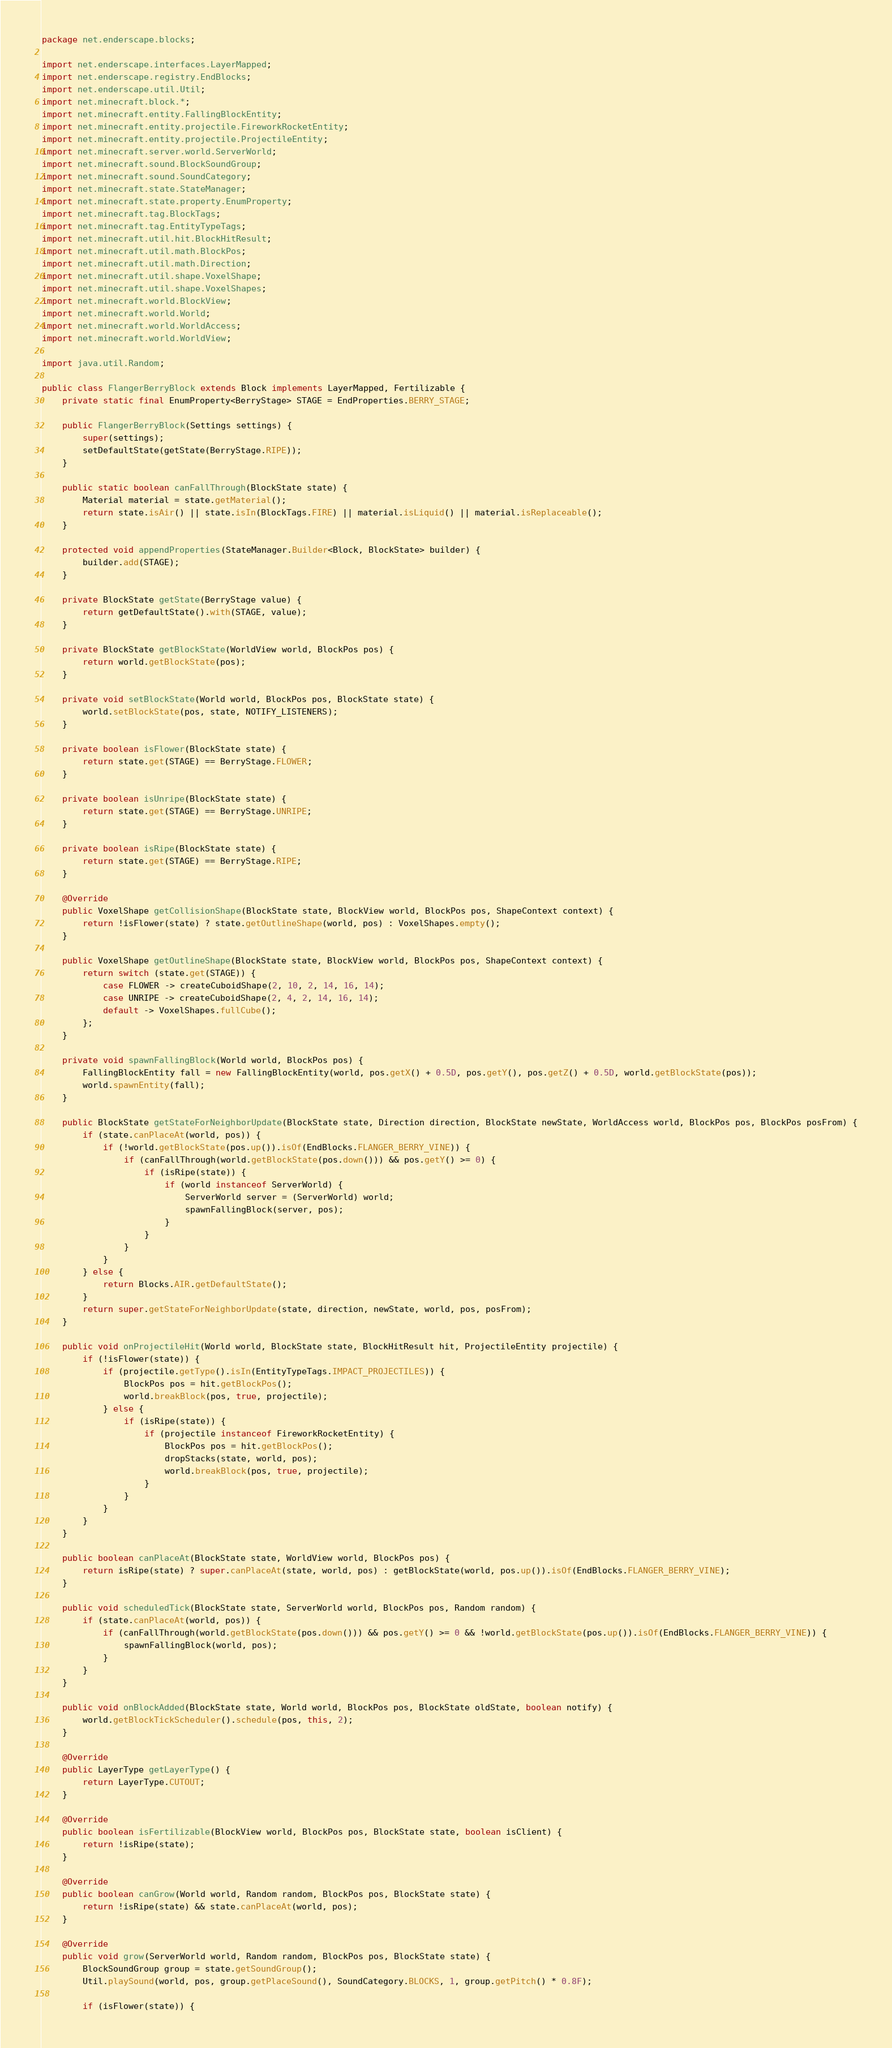Convert code to text. <code><loc_0><loc_0><loc_500><loc_500><_Java_>package net.enderscape.blocks;

import net.enderscape.interfaces.LayerMapped;
import net.enderscape.registry.EndBlocks;
import net.enderscape.util.Util;
import net.minecraft.block.*;
import net.minecraft.entity.FallingBlockEntity;
import net.minecraft.entity.projectile.FireworkRocketEntity;
import net.minecraft.entity.projectile.ProjectileEntity;
import net.minecraft.server.world.ServerWorld;
import net.minecraft.sound.BlockSoundGroup;
import net.minecraft.sound.SoundCategory;
import net.minecraft.state.StateManager;
import net.minecraft.state.property.EnumProperty;
import net.minecraft.tag.BlockTags;
import net.minecraft.tag.EntityTypeTags;
import net.minecraft.util.hit.BlockHitResult;
import net.minecraft.util.math.BlockPos;
import net.minecraft.util.math.Direction;
import net.minecraft.util.shape.VoxelShape;
import net.minecraft.util.shape.VoxelShapes;
import net.minecraft.world.BlockView;
import net.minecraft.world.World;
import net.minecraft.world.WorldAccess;
import net.minecraft.world.WorldView;

import java.util.Random;

public class FlangerBerryBlock extends Block implements LayerMapped, Fertilizable {
    private static final EnumProperty<BerryStage> STAGE = EndProperties.BERRY_STAGE;

    public FlangerBerryBlock(Settings settings) {
        super(settings);
        setDefaultState(getState(BerryStage.RIPE));
    }

    public static boolean canFallThrough(BlockState state) {
        Material material = state.getMaterial();
        return state.isAir() || state.isIn(BlockTags.FIRE) || material.isLiquid() || material.isReplaceable();
    }

    protected void appendProperties(StateManager.Builder<Block, BlockState> builder) {
        builder.add(STAGE);
    }

    private BlockState getState(BerryStage value) {
        return getDefaultState().with(STAGE, value);
    }

    private BlockState getBlockState(WorldView world, BlockPos pos) {
        return world.getBlockState(pos);
    }

    private void setBlockState(World world, BlockPos pos, BlockState state) {
        world.setBlockState(pos, state, NOTIFY_LISTENERS);
    }

    private boolean isFlower(BlockState state) {
        return state.get(STAGE) == BerryStage.FLOWER;
    }

    private boolean isUnripe(BlockState state) {
        return state.get(STAGE) == BerryStage.UNRIPE;
    }

    private boolean isRipe(BlockState state) {
        return state.get(STAGE) == BerryStage.RIPE;
    }

    @Override
    public VoxelShape getCollisionShape(BlockState state, BlockView world, BlockPos pos, ShapeContext context) {
        return !isFlower(state) ? state.getOutlineShape(world, pos) : VoxelShapes.empty();
    }

    public VoxelShape getOutlineShape(BlockState state, BlockView world, BlockPos pos, ShapeContext context) {
        return switch (state.get(STAGE)) {
            case FLOWER -> createCuboidShape(2, 10, 2, 14, 16, 14);
            case UNRIPE -> createCuboidShape(2, 4, 2, 14, 16, 14);
            default -> VoxelShapes.fullCube();
        };
    }

    private void spawnFallingBlock(World world, BlockPos pos) {
        FallingBlockEntity fall = new FallingBlockEntity(world, pos.getX() + 0.5D, pos.getY(), pos.getZ() + 0.5D, world.getBlockState(pos));
        world.spawnEntity(fall);
    }

    public BlockState getStateForNeighborUpdate(BlockState state, Direction direction, BlockState newState, WorldAccess world, BlockPos pos, BlockPos posFrom) {
        if (state.canPlaceAt(world, pos)) {
            if (!world.getBlockState(pos.up()).isOf(EndBlocks.FLANGER_BERRY_VINE)) {
                if (canFallThrough(world.getBlockState(pos.down())) && pos.getY() >= 0) {
                    if (isRipe(state)) {
                        if (world instanceof ServerWorld) {
                            ServerWorld server = (ServerWorld) world;
                            spawnFallingBlock(server, pos);
                        }
                    }
                }
            }
        } else {
            return Blocks.AIR.getDefaultState();
        }
        return super.getStateForNeighborUpdate(state, direction, newState, world, pos, posFrom);
    }

    public void onProjectileHit(World world, BlockState state, BlockHitResult hit, ProjectileEntity projectile) {
        if (!isFlower(state)) {
            if (projectile.getType().isIn(EntityTypeTags.IMPACT_PROJECTILES)) {
                BlockPos pos = hit.getBlockPos();
                world.breakBlock(pos, true, projectile);
            } else {
                if (isRipe(state)) {
                    if (projectile instanceof FireworkRocketEntity) {
                        BlockPos pos = hit.getBlockPos();
                        dropStacks(state, world, pos);
                        world.breakBlock(pos, true, projectile);
                    }
                }
            }
        }
    }

    public boolean canPlaceAt(BlockState state, WorldView world, BlockPos pos) {
        return isRipe(state) ? super.canPlaceAt(state, world, pos) : getBlockState(world, pos.up()).isOf(EndBlocks.FLANGER_BERRY_VINE);
    }

    public void scheduledTick(BlockState state, ServerWorld world, BlockPos pos, Random random) {
        if (state.canPlaceAt(world, pos)) {
            if (canFallThrough(world.getBlockState(pos.down())) && pos.getY() >= 0 && !world.getBlockState(pos.up()).isOf(EndBlocks.FLANGER_BERRY_VINE)) {
                spawnFallingBlock(world, pos);
            }
        }
    }

    public void onBlockAdded(BlockState state, World world, BlockPos pos, BlockState oldState, boolean notify) {
        world.getBlockTickScheduler().schedule(pos, this, 2);
    }

    @Override
    public LayerType getLayerType() {
        return LayerType.CUTOUT;
    }

    @Override
    public boolean isFertilizable(BlockView world, BlockPos pos, BlockState state, boolean isClient) {
        return !isRipe(state);
    }

    @Override
    public boolean canGrow(World world, Random random, BlockPos pos, BlockState state) {
        return !isRipe(state) && state.canPlaceAt(world, pos);
    }

    @Override
    public void grow(ServerWorld world, Random random, BlockPos pos, BlockState state) {
        BlockSoundGroup group = state.getSoundGroup();
        Util.playSound(world, pos, group.getPlaceSound(), SoundCategory.BLOCKS, 1, group.getPitch() * 0.8F);

        if (isFlower(state)) {</code> 